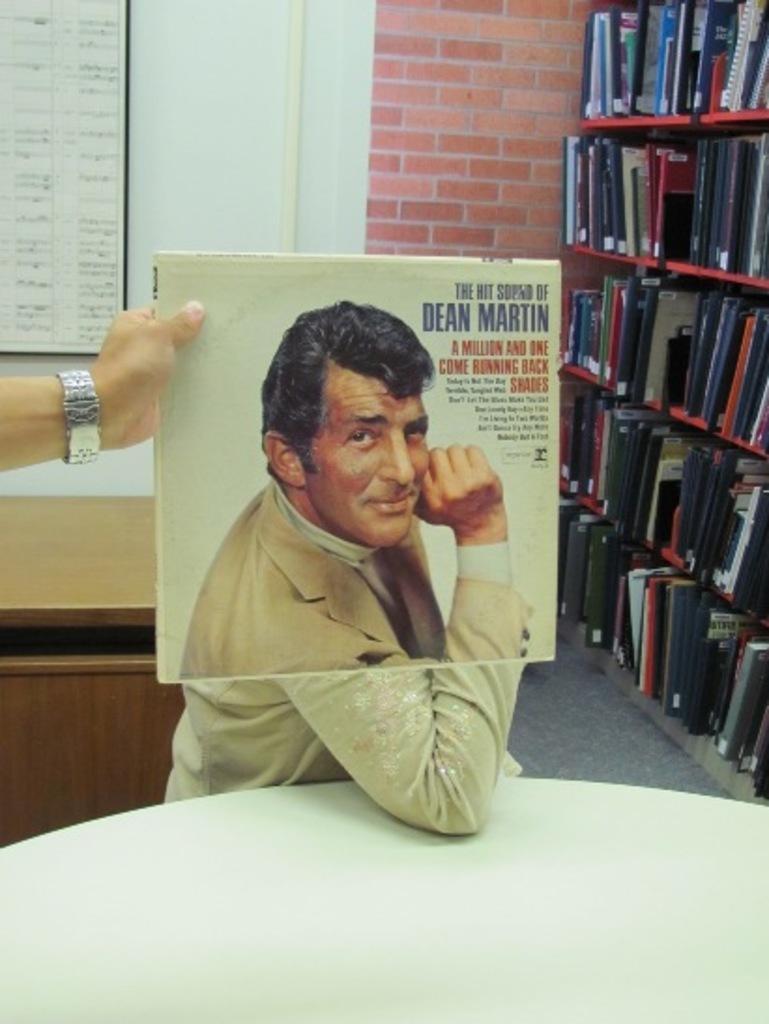In one or two sentences, can you explain what this image depicts? This picture looks like it is taken in a library. In the foreground of the picture there is a table. To the left there is a hand. In the middle of the picture there is a poster of a man seated. To the right there is a closet and books. To the top left there is a board. In the background there is a brick wall. On the left there is a desk. 